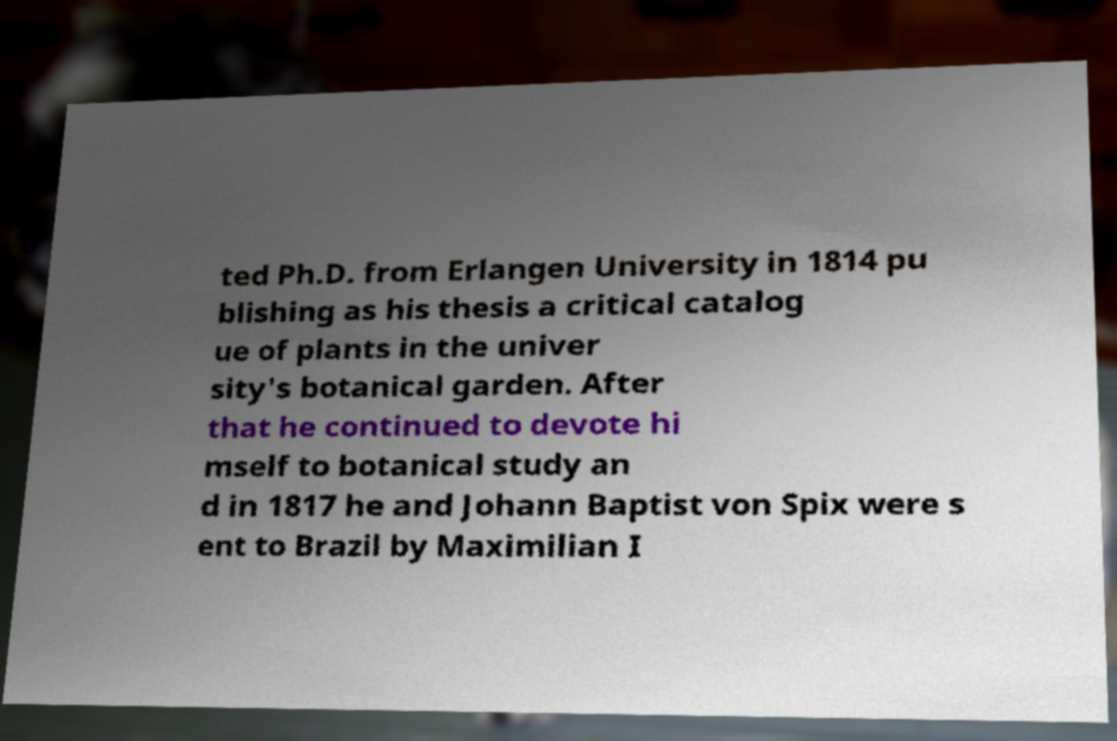Can you read and provide the text displayed in the image?This photo seems to have some interesting text. Can you extract and type it out for me? ted Ph.D. from Erlangen University in 1814 pu blishing as his thesis a critical catalog ue of plants in the univer sity's botanical garden. After that he continued to devote hi mself to botanical study an d in 1817 he and Johann Baptist von Spix were s ent to Brazil by Maximilian I 